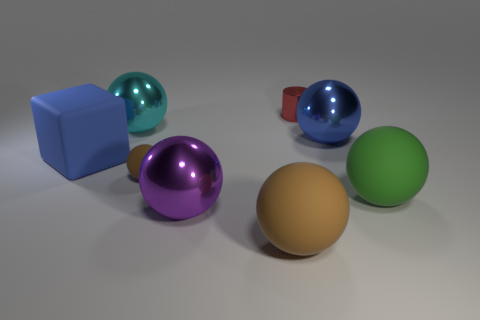Is the number of large blue balls behind the big cyan thing less than the number of green shiny blocks?
Offer a very short reply. No. What material is the purple object that is the same size as the green thing?
Your answer should be very brief. Metal. There is a thing that is behind the green rubber thing and in front of the cube; what size is it?
Make the answer very short. Small. What size is the other brown object that is the same shape as the large brown object?
Offer a very short reply. Small. How many things are big purple metallic spheres or rubber things behind the green ball?
Your answer should be compact. 3. What shape is the large blue rubber object?
Your response must be concise. Cube. What is the shape of the thing that is behind the big object that is behind the blue sphere?
Give a very brief answer. Cylinder. There is a large thing that is the same color as the tiny matte thing; what is its material?
Keep it short and to the point. Rubber. What color is the tiny cylinder that is made of the same material as the large cyan ball?
Make the answer very short. Red. Is the color of the tiny object that is in front of the cylinder the same as the big rubber sphere that is left of the tiny cylinder?
Make the answer very short. Yes. 